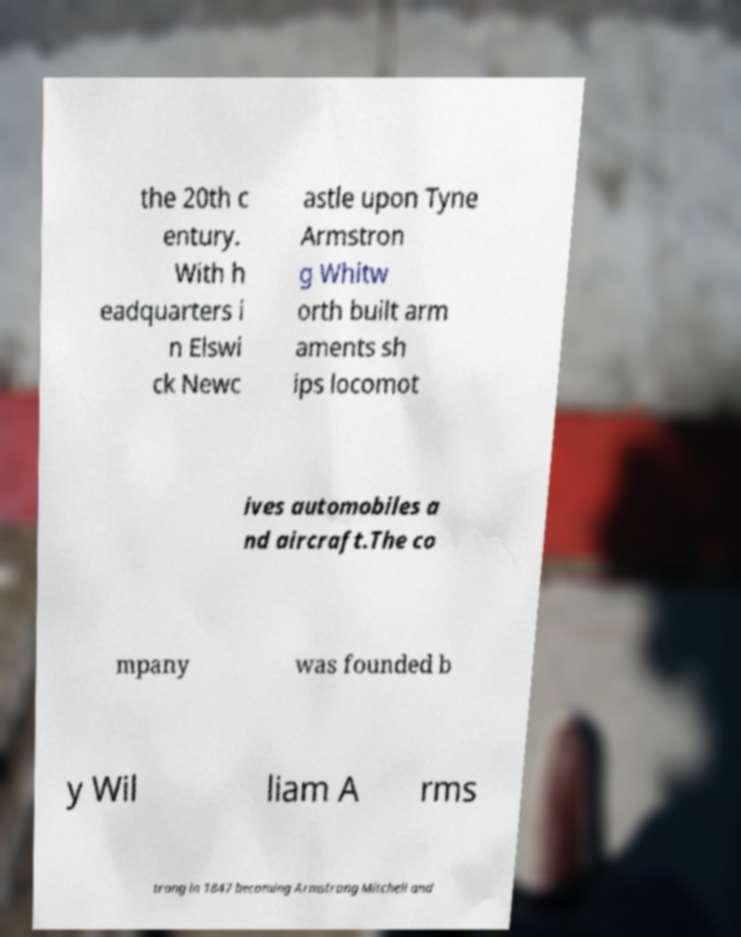Please read and relay the text visible in this image. What does it say? the 20th c entury. With h eadquarters i n Elswi ck Newc astle upon Tyne Armstron g Whitw orth built arm aments sh ips locomot ives automobiles a nd aircraft.The co mpany was founded b y Wil liam A rms trong in 1847 becoming Armstrong Mitchell and 